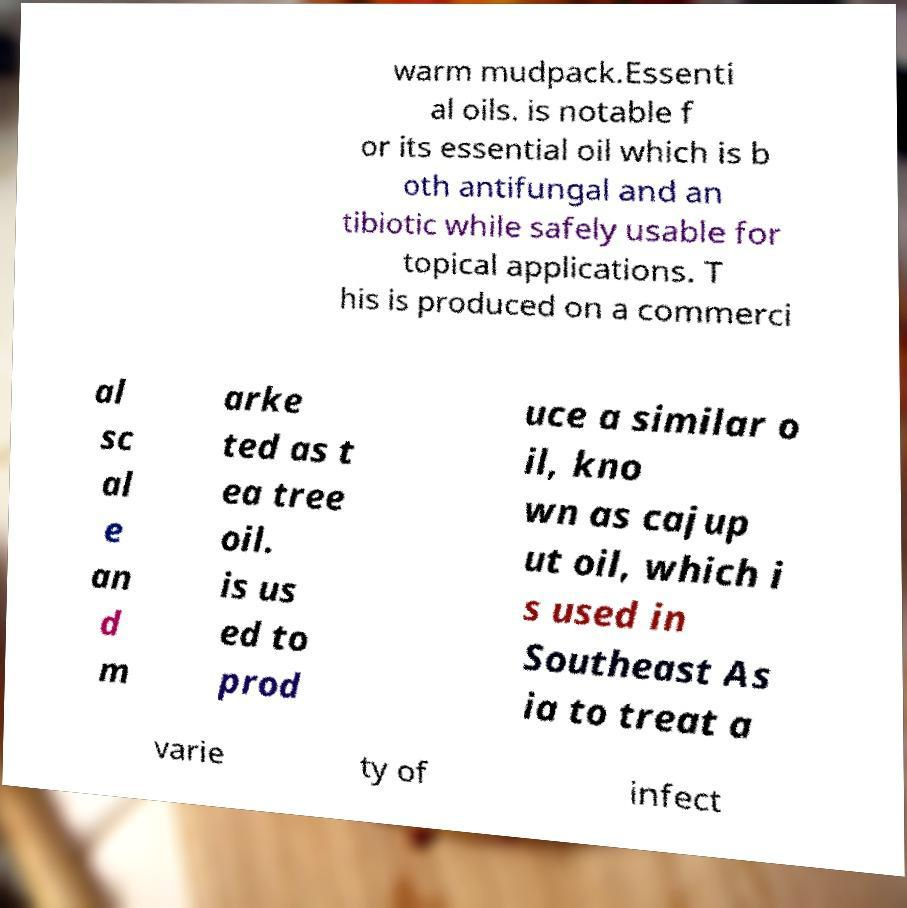What messages or text are displayed in this image? I need them in a readable, typed format. warm mudpack.Essenti al oils. is notable f or its essential oil which is b oth antifungal and an tibiotic while safely usable for topical applications. T his is produced on a commerci al sc al e an d m arke ted as t ea tree oil. is us ed to prod uce a similar o il, kno wn as cajup ut oil, which i s used in Southeast As ia to treat a varie ty of infect 